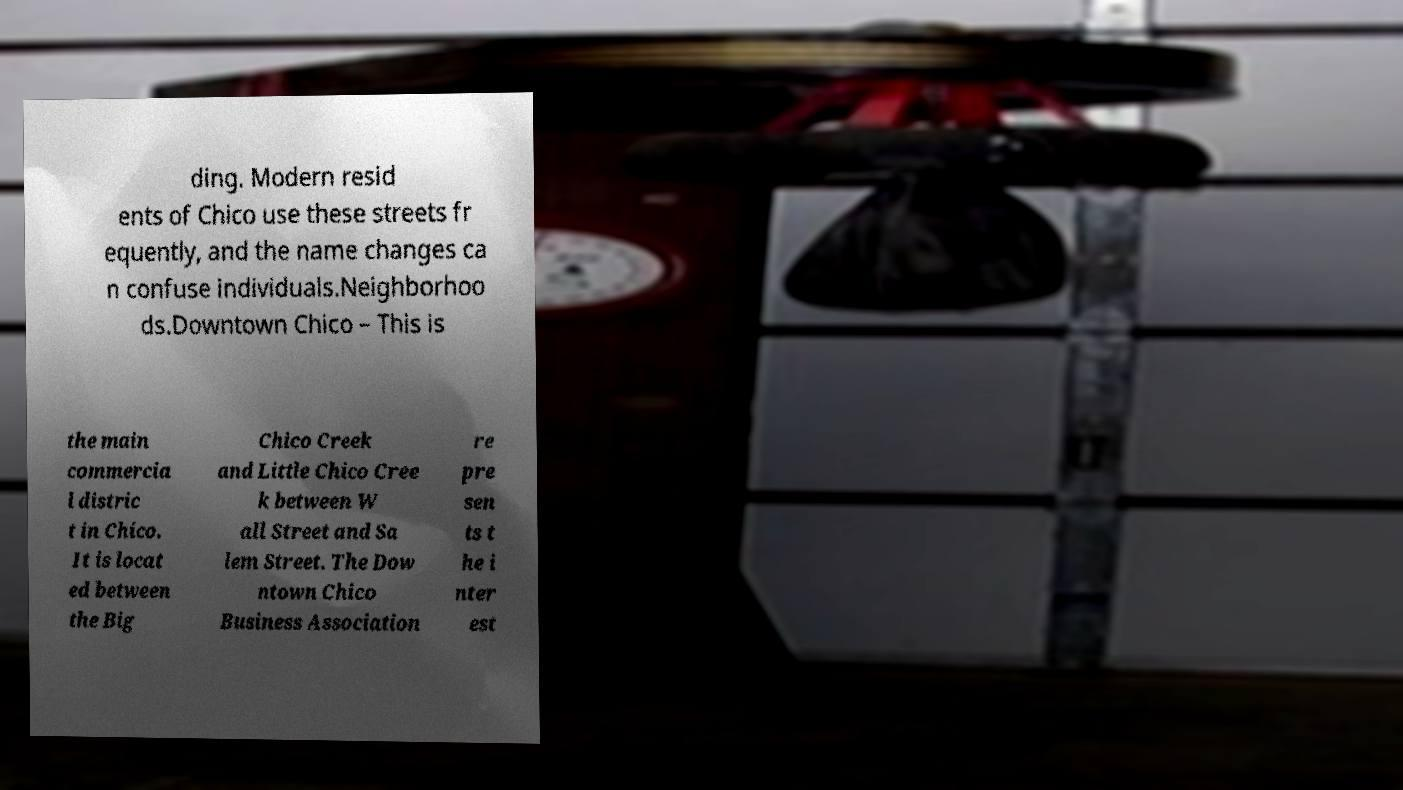Please read and relay the text visible in this image. What does it say? ding. Modern resid ents of Chico use these streets fr equently, and the name changes ca n confuse individuals.Neighborhoo ds.Downtown Chico – This is the main commercia l distric t in Chico. It is locat ed between the Big Chico Creek and Little Chico Cree k between W all Street and Sa lem Street. The Dow ntown Chico Business Association re pre sen ts t he i nter est 